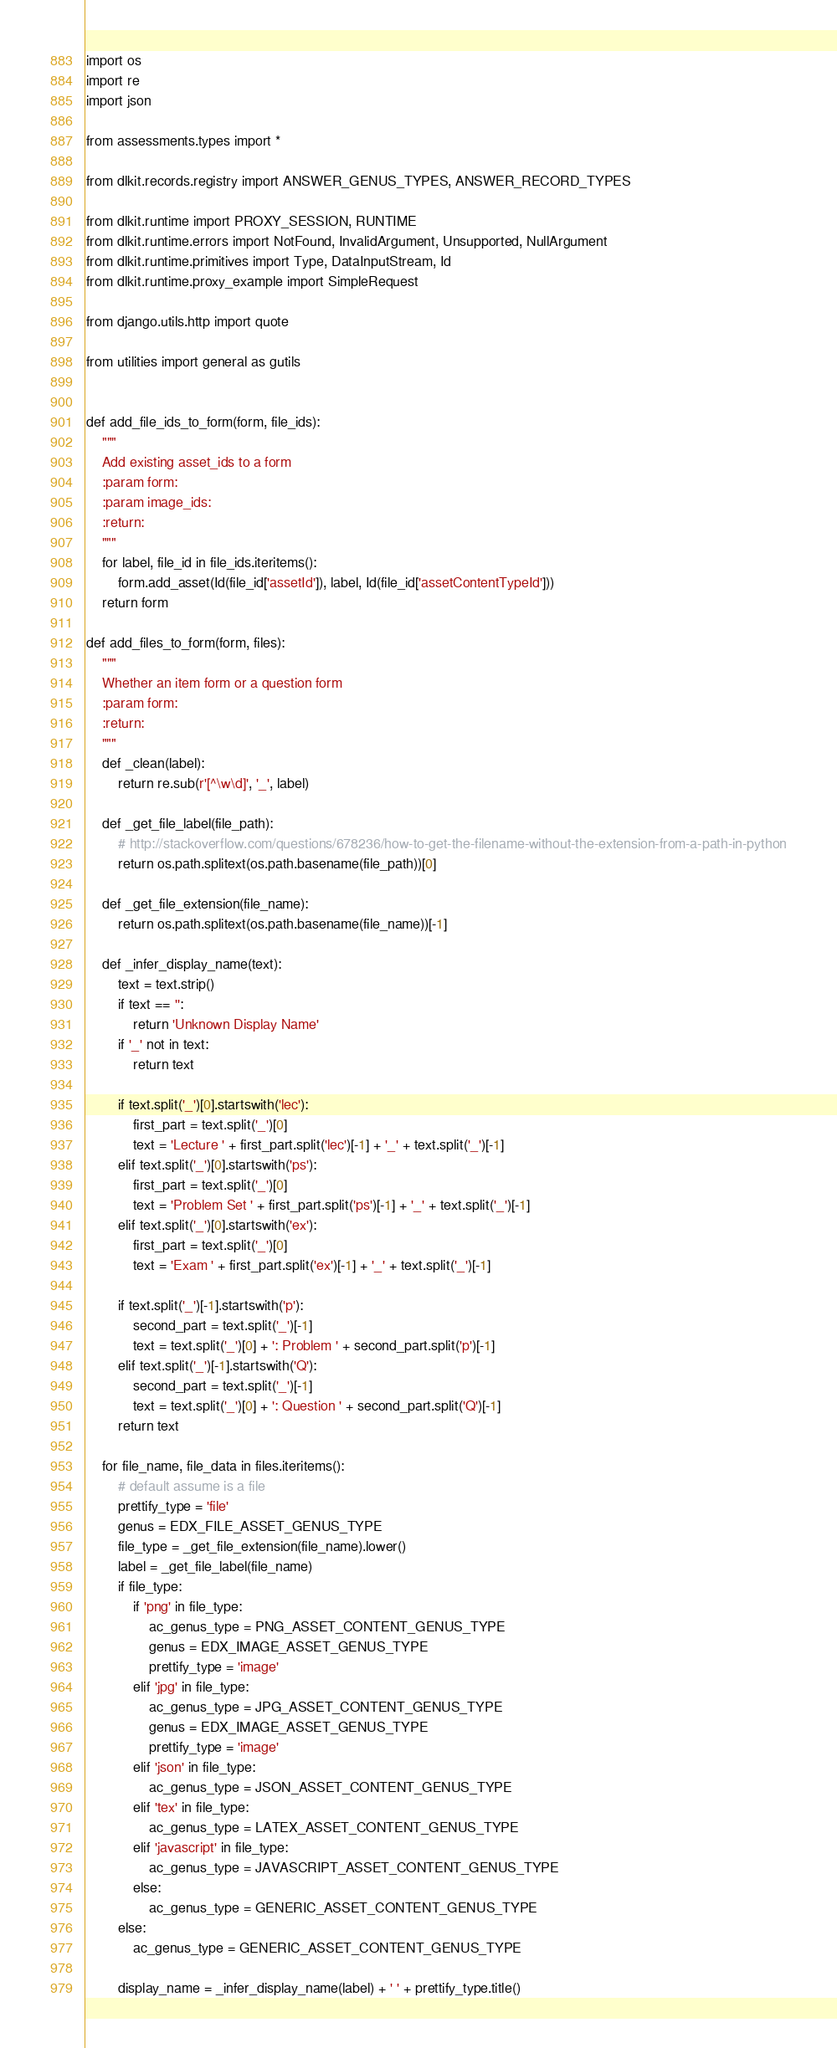Convert code to text. <code><loc_0><loc_0><loc_500><loc_500><_Python_>import os
import re
import json

from assessments.types import *

from dlkit.records.registry import ANSWER_GENUS_TYPES, ANSWER_RECORD_TYPES

from dlkit.runtime import PROXY_SESSION, RUNTIME
from dlkit.runtime.errors import NotFound, InvalidArgument, Unsupported, NullArgument
from dlkit.runtime.primitives import Type, DataInputStream, Id
from dlkit.runtime.proxy_example import SimpleRequest

from django.utils.http import quote

from utilities import general as gutils


def add_file_ids_to_form(form, file_ids):
    """
    Add existing asset_ids to a form
    :param form:
    :param image_ids:
    :return:
    """
    for label, file_id in file_ids.iteritems():
        form.add_asset(Id(file_id['assetId']), label, Id(file_id['assetContentTypeId']))
    return form

def add_files_to_form(form, files):
    """
    Whether an item form or a question form
    :param form:
    :return:
    """
    def _clean(label):
        return re.sub(r'[^\w\d]', '_', label)

    def _get_file_label(file_path):
        # http://stackoverflow.com/questions/678236/how-to-get-the-filename-without-the-extension-from-a-path-in-python
        return os.path.splitext(os.path.basename(file_path))[0]

    def _get_file_extension(file_name):
        return os.path.splitext(os.path.basename(file_name))[-1]

    def _infer_display_name(text):
        text = text.strip()
        if text == '':
            return 'Unknown Display Name'
        if '_' not in text:
            return text

        if text.split('_')[0].startswith('lec'):
            first_part = text.split('_')[0]
            text = 'Lecture ' + first_part.split('lec')[-1] + '_' + text.split('_')[-1]
        elif text.split('_')[0].startswith('ps'):
            first_part = text.split('_')[0]
            text = 'Problem Set ' + first_part.split('ps')[-1] + '_' + text.split('_')[-1]
        elif text.split('_')[0].startswith('ex'):
            first_part = text.split('_')[0]
            text = 'Exam ' + first_part.split('ex')[-1] + '_' + text.split('_')[-1]

        if text.split('_')[-1].startswith('p'):
            second_part = text.split('_')[-1]
            text = text.split('_')[0] + ': Problem ' + second_part.split('p')[-1]
        elif text.split('_')[-1].startswith('Q'):
            second_part = text.split('_')[-1]
            text = text.split('_')[0] + ': Question ' + second_part.split('Q')[-1]
        return text

    for file_name, file_data in files.iteritems():
        # default assume is a file
        prettify_type = 'file'
        genus = EDX_FILE_ASSET_GENUS_TYPE
        file_type = _get_file_extension(file_name).lower()
        label = _get_file_label(file_name)
        if file_type:
            if 'png' in file_type:
                ac_genus_type = PNG_ASSET_CONTENT_GENUS_TYPE
                genus = EDX_IMAGE_ASSET_GENUS_TYPE
                prettify_type = 'image'
            elif 'jpg' in file_type:
                ac_genus_type = JPG_ASSET_CONTENT_GENUS_TYPE
                genus = EDX_IMAGE_ASSET_GENUS_TYPE
                prettify_type = 'image'
            elif 'json' in file_type:
                ac_genus_type = JSON_ASSET_CONTENT_GENUS_TYPE
            elif 'tex' in file_type:
                ac_genus_type = LATEX_ASSET_CONTENT_GENUS_TYPE
            elif 'javascript' in file_type:
                ac_genus_type = JAVASCRIPT_ASSET_CONTENT_GENUS_TYPE
            else:
                ac_genus_type = GENERIC_ASSET_CONTENT_GENUS_TYPE
        else:
            ac_genus_type = GENERIC_ASSET_CONTENT_GENUS_TYPE

        display_name = _infer_display_name(label) + ' ' + prettify_type.title()</code> 